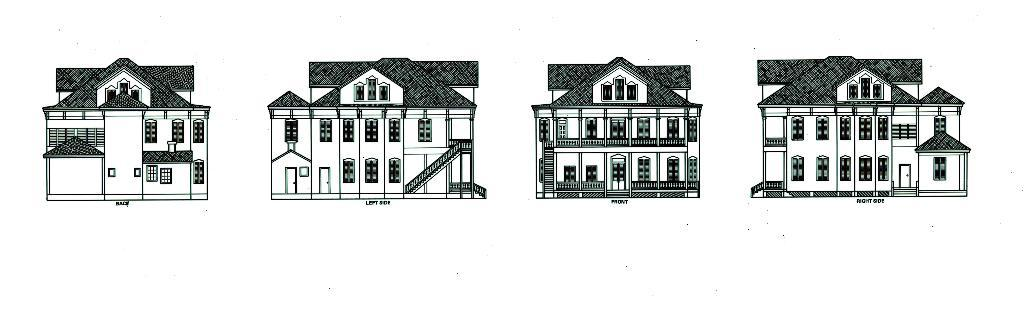What is the main subject of the image? The main subject of the image is an art or sketch of four buildings. What can be seen at the bottom of each building in the image? There is text written at the bottom of each building in the image. What color is the background of the image? The background of the image is white in color. What type of glass can be seen in the image? There is no glass present in the image; it contains an art or sketch of four buildings with text at the bottom of each building and a white background. 